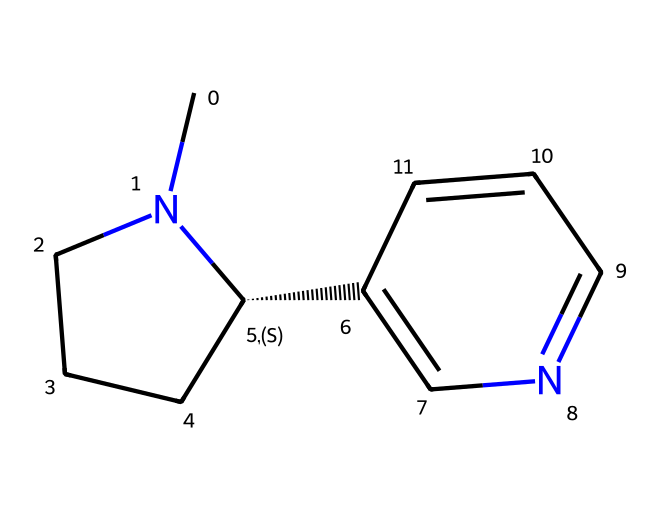What is the molecular formula of nicotine? To determine the molecular formula, we can count the number of each type of atom present in the SMILES representation. In the structure, there are 10 carbon atoms (C), 14 hydrogen atoms (H), and 2 nitrogen atoms (N). Therefore, the molecular formula is C10H14N2.
Answer: C10H14N2 How many rings are present in the nicotine structure? By analyzing the SMILES representation, we can identify the ring structures. There are two numbers in the structure (1 and 2) that indicate the positions where the rings are closed. Thus, there are two rings in the structure.
Answer: 2 What type of toxic chemical is nicotine classified as? Nicotine is classified as an alkaloid due to its nitrogen-containing structure and its physiological effects. Alkaloids are a class of compounds that often have significant pharmacological effects.
Answer: alkaloid How many nitrogen atoms are present in the nicotine structure? By examining the SMILES notation, we observe that there are two nitrogen atoms represented by 'N' in the structure. Counting these gives us a total of two nitrogen atoms.
Answer: 2 What is one main effect of nicotine as a toxic substance? Nicotine primarily acts as a stimulant in the human body, affecting the central nervous system and leading to increased heart rate and blood pressure. This is a well-known effect of nicotine, which contributes to its classification as a toxic substance.
Answer: stimulant Which functional group is present in nicotine? The key functional group in nicotine is the pyridine ring and the piperidine ring, which contain nitrogen atoms and are essential to its biological activity and toxicity. The presence of these rings characterizes nicotine as an alkaloid.
Answer: pyridine and piperidine rings 